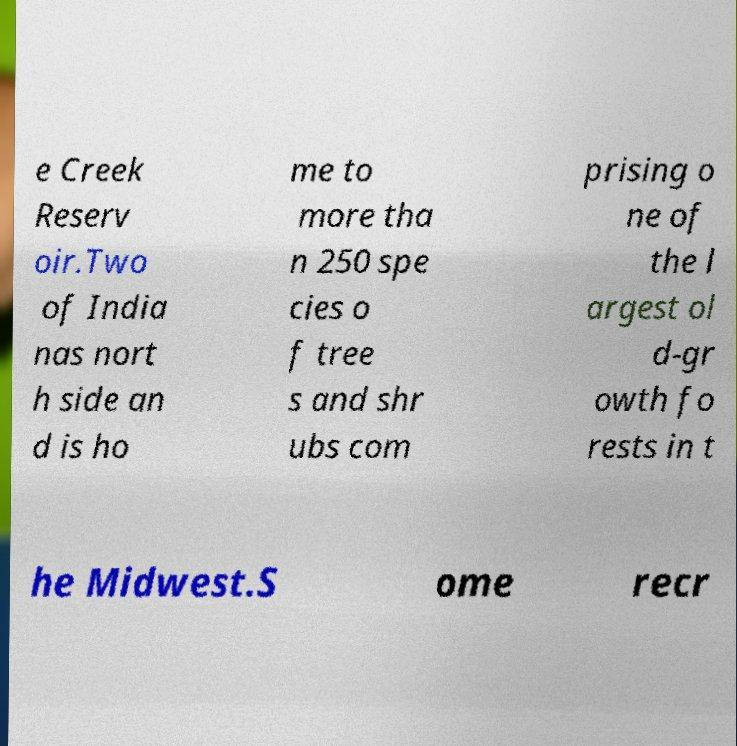I need the written content from this picture converted into text. Can you do that? e Creek Reserv oir.Two of India nas nort h side an d is ho me to more tha n 250 spe cies o f tree s and shr ubs com prising o ne of the l argest ol d-gr owth fo rests in t he Midwest.S ome recr 